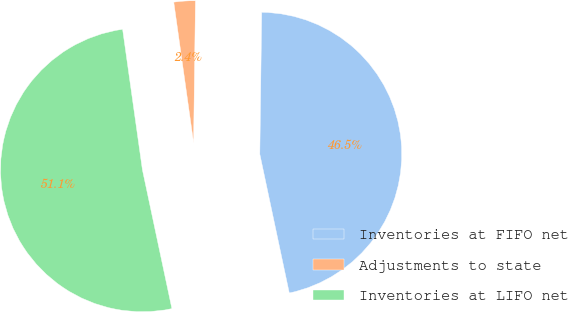Convert chart. <chart><loc_0><loc_0><loc_500><loc_500><pie_chart><fcel>Inventories at FIFO net<fcel>Adjustments to state<fcel>Inventories at LIFO net<nl><fcel>46.46%<fcel>2.44%<fcel>51.1%<nl></chart> 